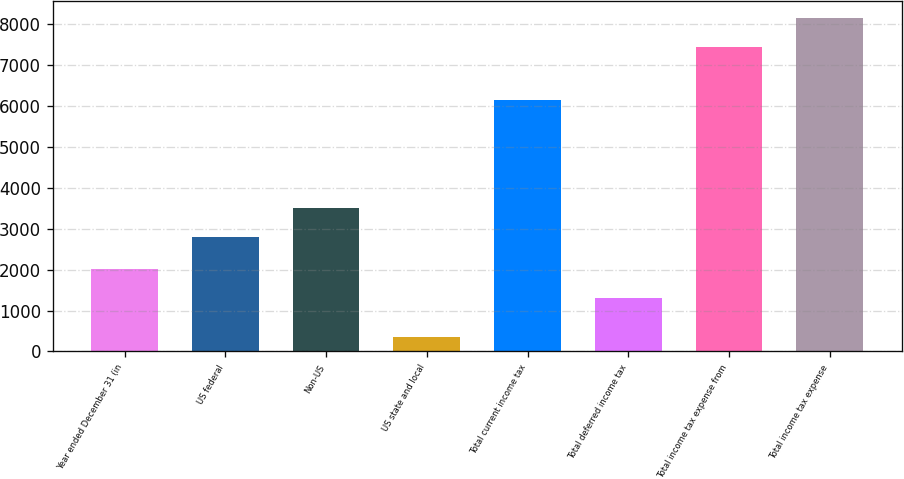Convert chart. <chart><loc_0><loc_0><loc_500><loc_500><bar_chart><fcel>Year ended December 31 (in<fcel>US federal<fcel>Non-US<fcel>US state and local<fcel>Total current income tax<fcel>Total deferred income tax<fcel>Total income tax expense from<fcel>Total income tax expense<nl><fcel>2016.7<fcel>2805<fcel>3514.7<fcel>343<fcel>6133<fcel>1307<fcel>7440<fcel>8149.7<nl></chart> 